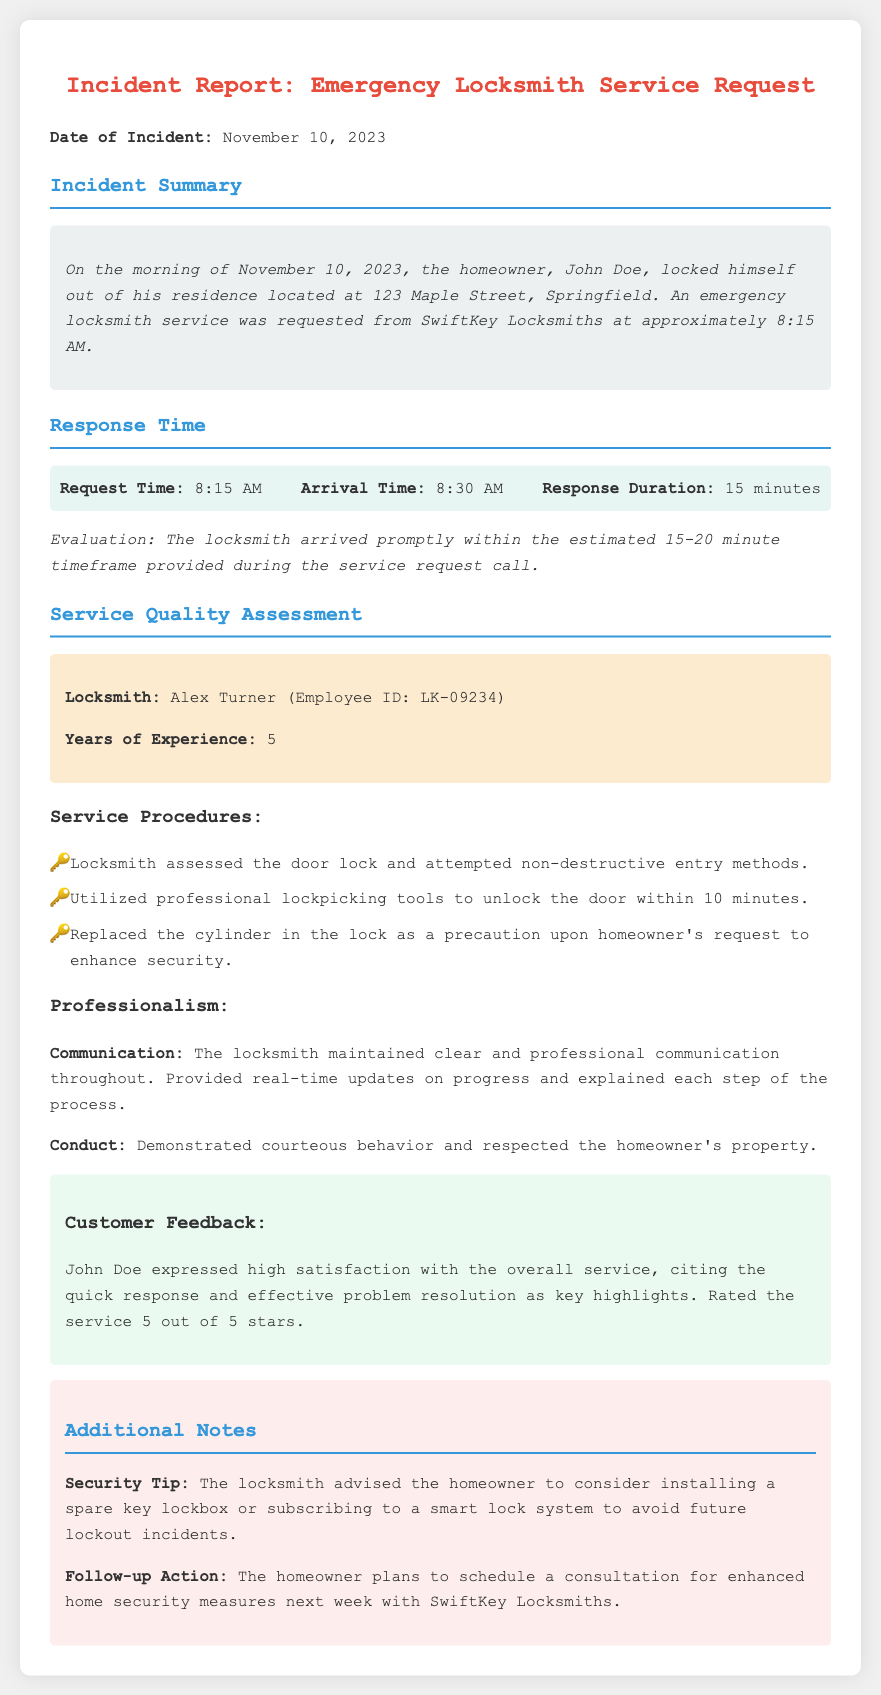What is the date of the incident? The date of the incident is provided at the beginning of the report.
Answer: November 10, 2023 Who was the homeowner in this incident? The homeowner's name is mentioned in the incident summary section of the report.
Answer: John Doe What time did the locksmith arrive? The arrival time of the locksmith is listed under the response time section of the report.
Answer: 8:30 AM How long did it take for the locksmith to respond? The response duration is specified in the response time section.
Answer: 15 minutes What rating did John Doe give the service? The customer feedback section includes the homeowner's rating for the service.
Answer: 5 out of 5 stars What security tip was provided by the locksmith? The additional notes section contains the security tip advised by the locksmith.
Answer: Installing a spare key lockbox How many years of experience does the locksmith have? The years of experience for the locksmith is noted in the locksmith details section.
Answer: 5 What was the locksmith's name? The name of the locksmith is detailed in the locksmith details section.
Answer: Alex Turner What was one of the locksmith's procedures during the service? The service procedures list specific actions taken by the locksmith.
Answer: Utilized professional lockpicking tools 